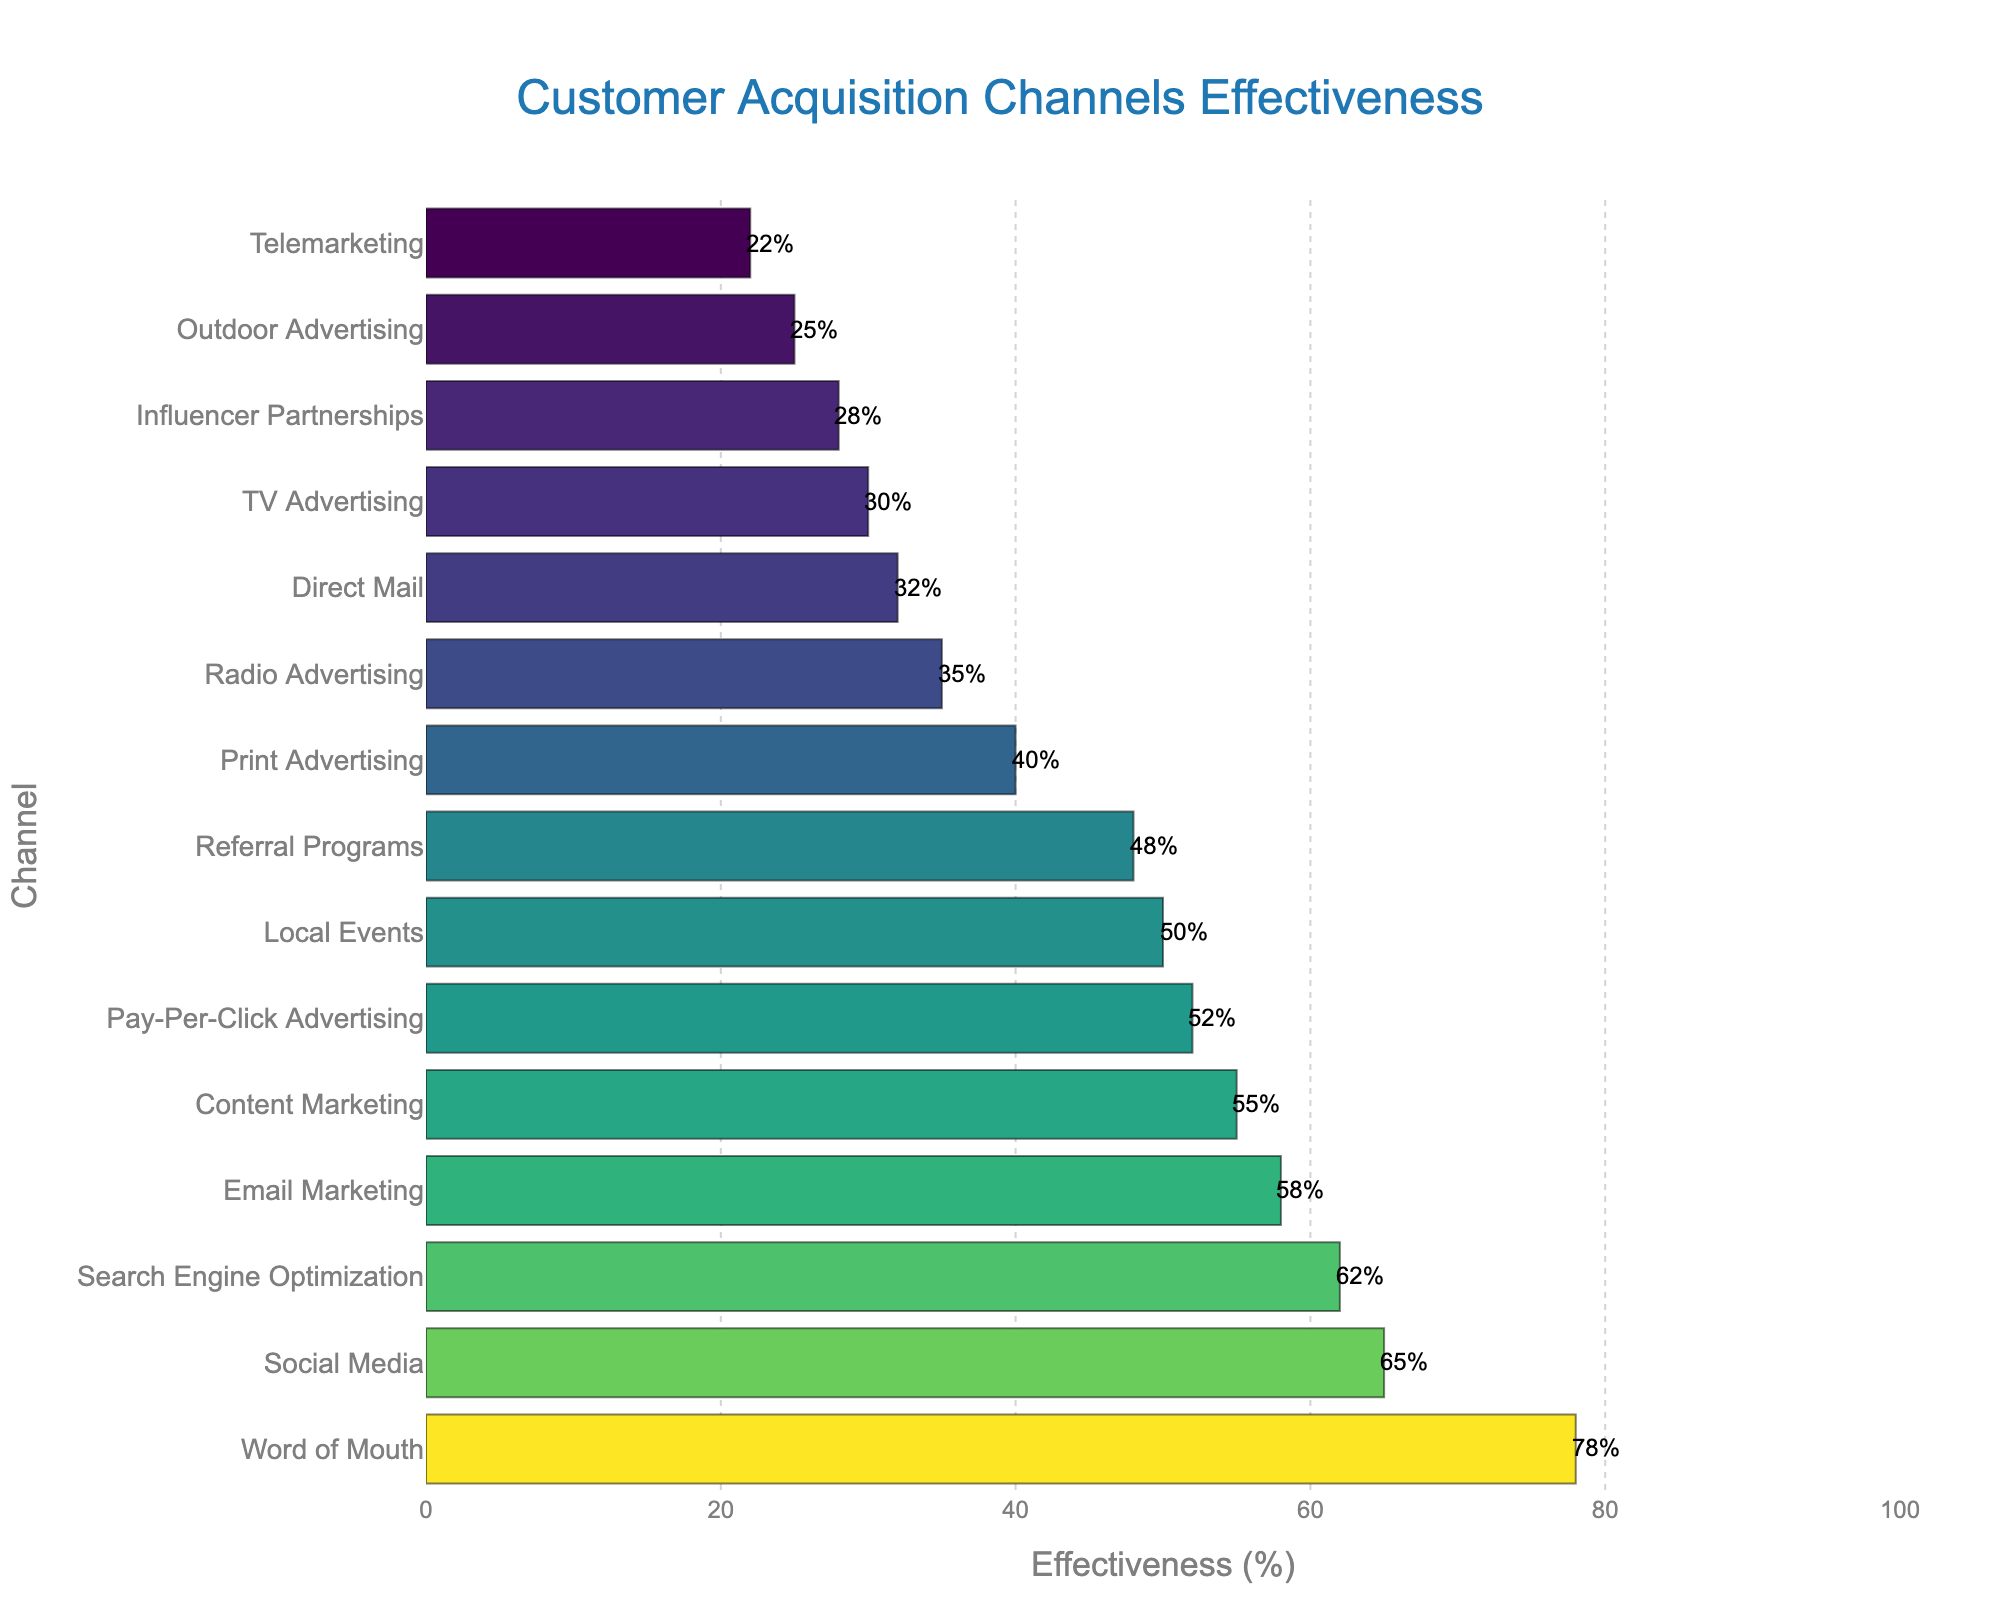what is the most effective customer acquisition channel? The bar chart visually shows the effectiveness of different customer acquisition channels, with "Word of Mouth" having the longest bar at 78%, making it the most effective channel
Answer: Word of Mouth which is more effective, social media or email marketing? To compare the effectiveness of "Social Media" and "Email Marketing," look at the length of their bars. "Social Media" has an effectiveness of 65%, while "Email Marketing" has 58%, indicating Social Media is more effective.
Answer: Social Media what is the difference in effectiveness between pay-per-click advertising and tv advertising? The effectiveness of "Pay-Per-Click Advertising" and "TV Advertising" are 52% and 30% respectively. The difference is calculated as 52% - 30% = 22%.
Answer: 22% how many channels have an effectiveness of over 50%? Count the number of bars that have lengths representing effectiveness over 50%. These are "Word of Mouth," "Social Media," "Search Engine Optimization," "Email Marketing," "Content Marketing," and "Pay-Per-Click Advertising" (6 channels).
Answer: 6 which channel has higher effectiveness, local events or print advertising? Compare the lengths of the bars for "Local Events" and "Print Advertising." "Local Events" has an effectiveness of 50%, whereas "Print Advertising" has 40%, showing that Local Events is higher.
Answer: Local Events what is the average effectiveness of influencer partnerships, outdoor advertising, and telemarketing? To find the average effectiveness, add the effectiveness percentages of "Influencer Partnerships" (28%), "Outdoor Advertising" (25%), and "Telemarketing" (22%), then divide by 3: (28 + 25 + 22) / 3 = 25%.
Answer: 25% what is the second least effective customer acquisition channel? By visually inspecting the chart, the bars representing effectiveness show "Telemarketing" as the least effective at 22%. The bar just above it is "Outdoor Advertising" at 25%, making it the second least effective.
Answer: Outdoor Advertising how much more effective is search engine optimization compared to radio advertising? Compare the effectiveness of "Search Engine Optimization" (62%) and "Radio Advertising" (35%). The difference is calculated as 62% - 35% = 27%.
Answer: 27% which channels have effectiveness values between 45% and 60%? Identify the bars whose effectiveness values fall between 45% and 60%. These channels are "Email Marketing" (58%), "Content Marketing" (55%), "Pay-Per-Click Advertising" (52%), "Local Events" (50%), and "Referral Programs" (48%).
Answer: Email Marketing, Content Marketing, Pay-Per-Click Advertising, Local Events, Referral Programs 